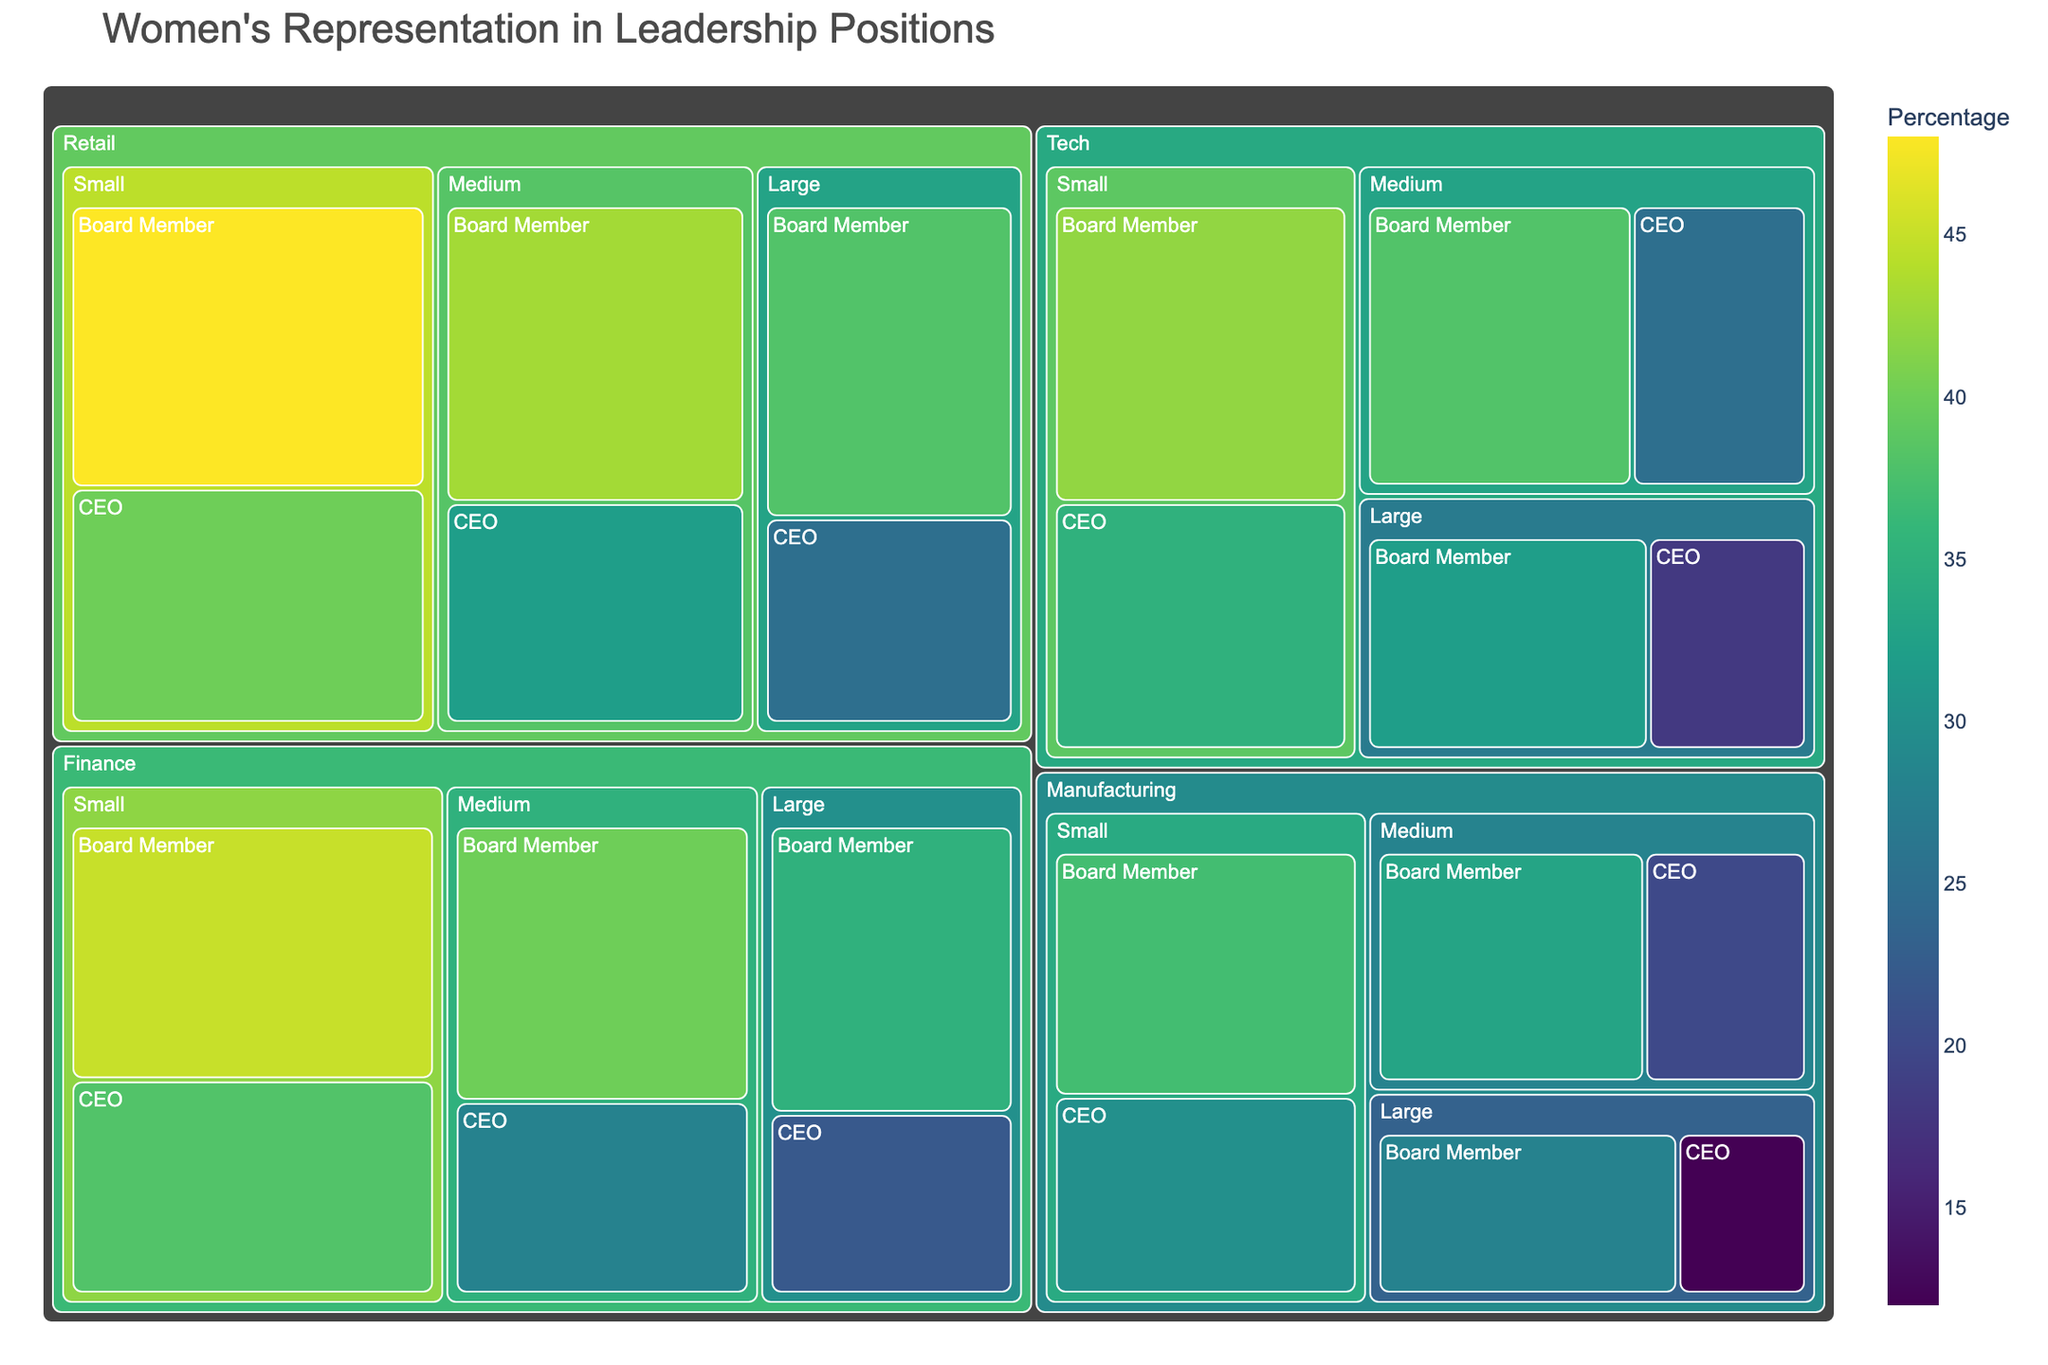What's the title of the Treemap? The Treemap's title is usually prominently displayed at the top of the figure. In this case, the title is "Women's Representation in Leadership Positions".
Answer: Women's Representation in Leadership Positions Which company type has the highest percentage of women as Board Members in small companies? Locate the section for small companies within each company type and identify the Board Member categories. Compare the percentages and find the highest value. Retail has the highest percentage at 48%.
Answer: Retail What is the percentage difference of women CEOs between large Tech companies and large Manufacturing companies? Find the percentage for women CEOs in large Tech companies (18%) and large Manufacturing companies (12%). Subtract the two values: 18% - 12% = 6%.
Answer: 6% Which company size has the highest average percentage of women in leadership positions across all company types? Calculate the average percentage of women in leadership positions (both CEO and Board Member) for each company size. Small companies have the highest averages:
Tech: (35+42)/2=38.5%
Manufacturing: (30+37)/2=33.5%
Finance: (38+45)/2=41.5%
Retail: (40+48)/2=44%
Midpoint between .
Answer: Small Do medium or large companies in the Finance sector have a higher percentage of women CEOs? Compare the percentage of women CEOs specifically in medium Finance companies (28%) and large Finance companies (22%). Medium companies have a higher percentage.
Answer: Medium In which company type and size combination do women represent more than 40% in any leadership position? Look for segments where the percentage is above 40%. In the Retail sector (both medium and small companies) and in Finance's small companies, the percentages exceed 40%.
Answer: Retail Small, Retail Medium, Finance Small What is the color scale used for indicating the percentage values in the Treemap? The color scale is described in the code as 'Viridis', which varies in color depending on the percentage values.
Answer: Viridis Which position has the smallest representation of women in large companies across all sectors? Identify the smallest percentage value related to the CEO or Board Member positions in large companies. The smallest value is for manufacturing firms’ CEOs at 12%.
Answer: CEO in Manufacturing Are Board Members more represented than CEOs across all company sizes in the tech sector? Compare the percentages of Board Members and CEOs within the Tech sector for large, medium, and small companies. In all cases, Board Members have higher percentages:
Large: 32% > 18%
Medium: 38% > 25%
Small: 42% > 35%
Hence, board members are more represented.
Answer: Yes Is there any overlap where women CEOs in small companies exceed 35% across multiple sectors? Check the data for women CEOs in small companies across all sectors. Retail (40%) and Finance (38%) exceed 35%.
Answer: Yes 